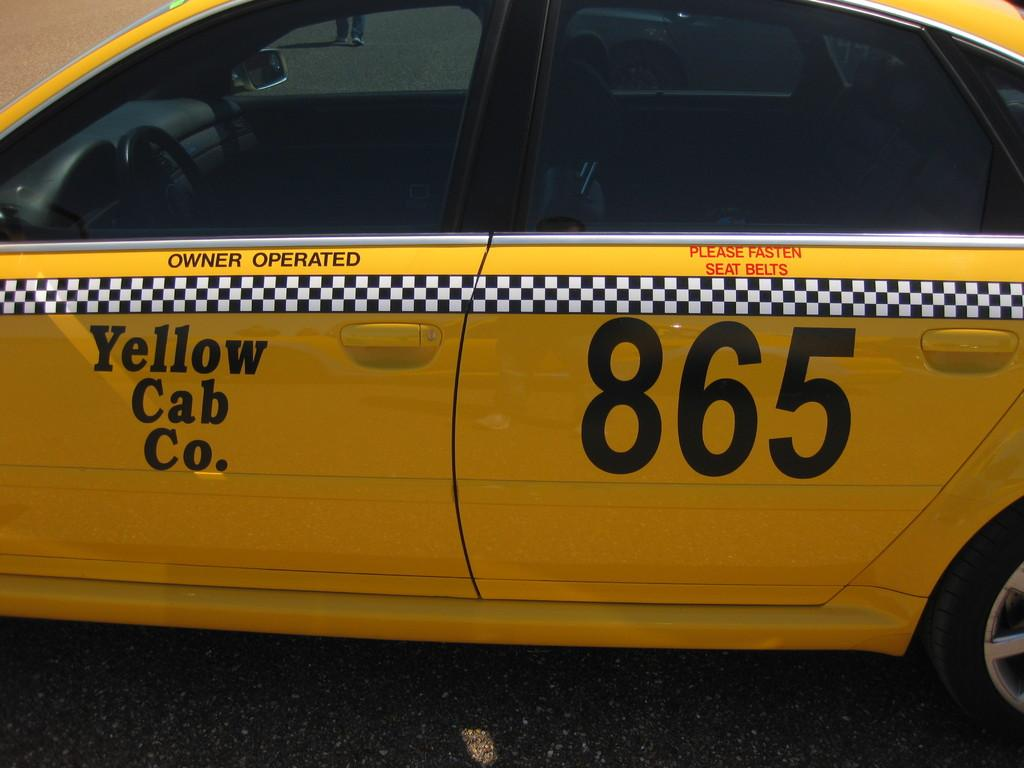<image>
Share a concise interpretation of the image provided. Yellow Cab number 865 has a reminder on it in red to fasten your seat belts. 